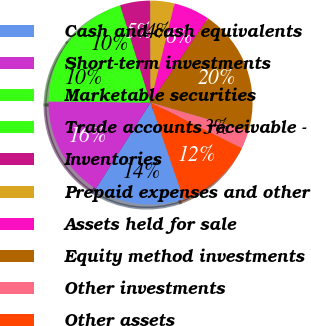Convert chart to OTSL. <chart><loc_0><loc_0><loc_500><loc_500><pie_chart><fcel>Cash and cash equivalents<fcel>Short-term investments<fcel>Marketable securities<fcel>Trade accounts receivable -<fcel>Inventories<fcel>Prepaid expenses and other<fcel>Assets held for sale<fcel>Equity method investments<fcel>Other investments<fcel>Other assets<nl><fcel>14.27%<fcel>16.17%<fcel>10.47%<fcel>9.53%<fcel>4.78%<fcel>3.83%<fcel>5.73%<fcel>19.97%<fcel>2.88%<fcel>12.37%<nl></chart> 